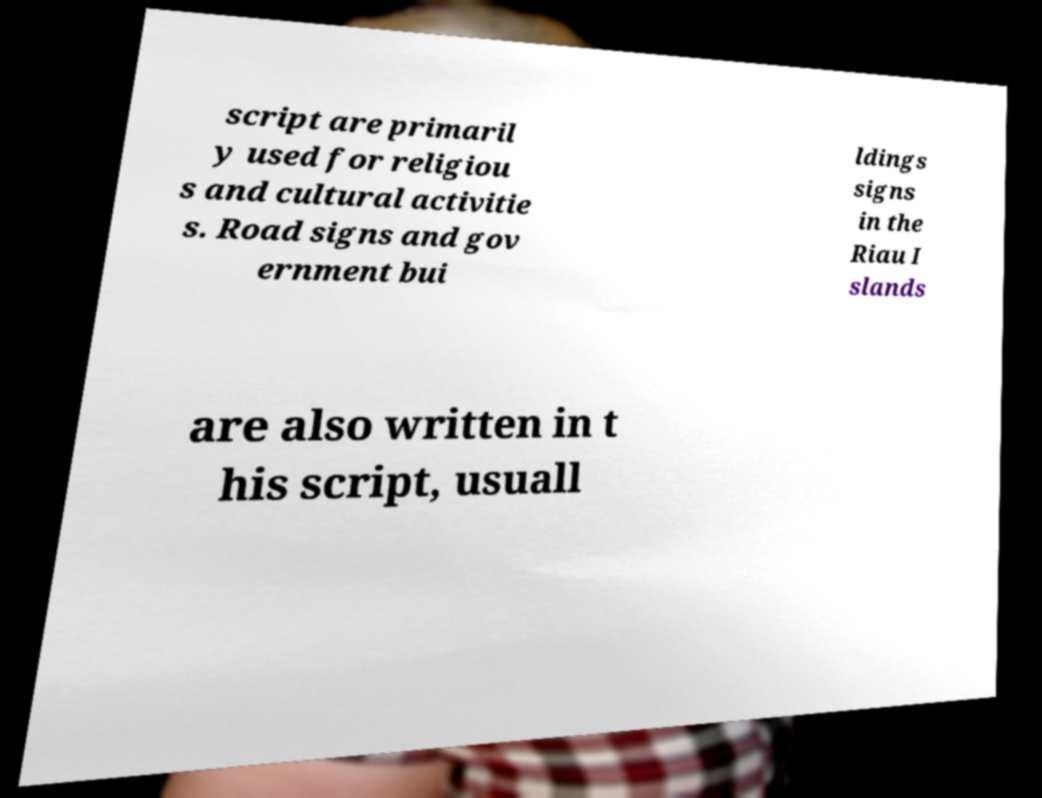Can you read and provide the text displayed in the image?This photo seems to have some interesting text. Can you extract and type it out for me? script are primaril y used for religiou s and cultural activitie s. Road signs and gov ernment bui ldings signs in the Riau I slands are also written in t his script, usuall 